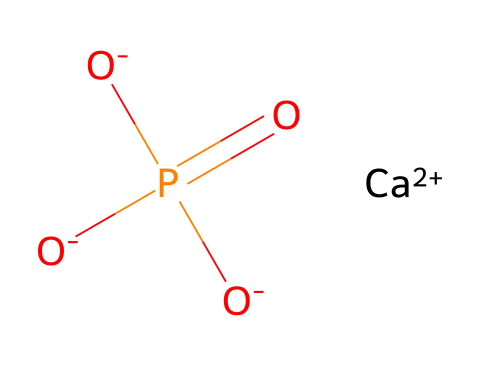What is the central atom in this compound? The structure indicates that phosphorus (P) is in the center, surrounded by oxygen atoms due to its connectivity in the phosphate group.
Answer: phosphorus How many oxygen atoms are bonded to phosphorus? By analyzing the SMILES representation, there are three oxygen atoms that are connected to the phosphorus atom in the indicated phosphate structure.
Answer: three What is the charge of the calcium ion in this compound? The notation [Ca+2] specifies that calcium has a +2 charge; it is important in balancing the charge of the phosphate ions in the fertilizer.
Answer: +2 What functional group is present in this compound? The phosphate group, represented as P(=O)([O-])[O-], is characterized by a phosphorus atom bonded to four oxygen atoms, with one double bond to an oxygen.
Answer: phosphate group How does this compound contribute to soil fertility? Phosphate compounds are crucial as they provide essential nutrients, especially phosphorus, directly involved in photosynthesis and energy transfer for plants.
Answer: nutrients What is the total number of atoms in this compound? By counting the atoms in the formula, we find there are one calcium, one phosphorus, and three oxygen atoms, totaling five atoms in the compound.
Answer: five atoms What type of bond is formed between phosphorus and oxygen in this compound? The presence of P(=O) indicates a double bond between phosphorus and one oxygen atom, while the others are single bonded; hence, both single and double bonds are present here.
Answer: double and single bonds 